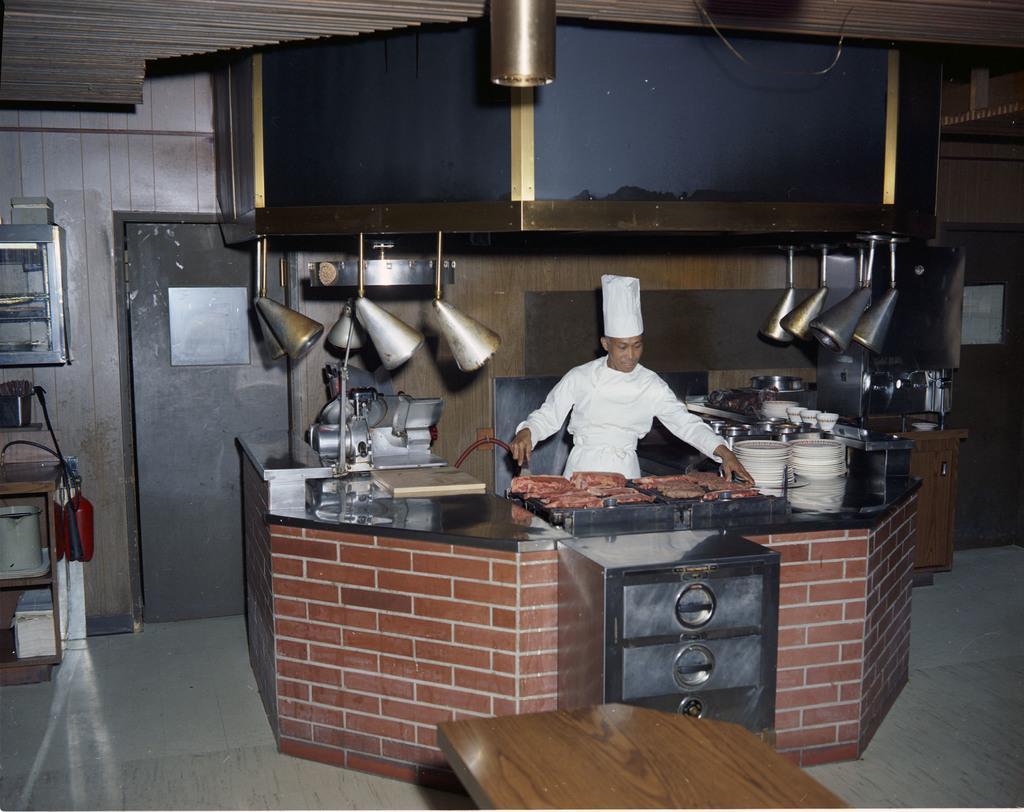How would you summarize this image in a sentence or two? There is a person standing wearing a cap. He is holding something. In front of him there is a table. On that there is a food item, book, plates, cups and many other items. Also there is a steel cupboard and a brick wall. In front of that there is a table. On the left side there is a table. Inside that there are many items. Also there is a fire extinguisher. On the wall there is a cupboard. In the back there is a door. And there are some other items hanged on the ceiling. 